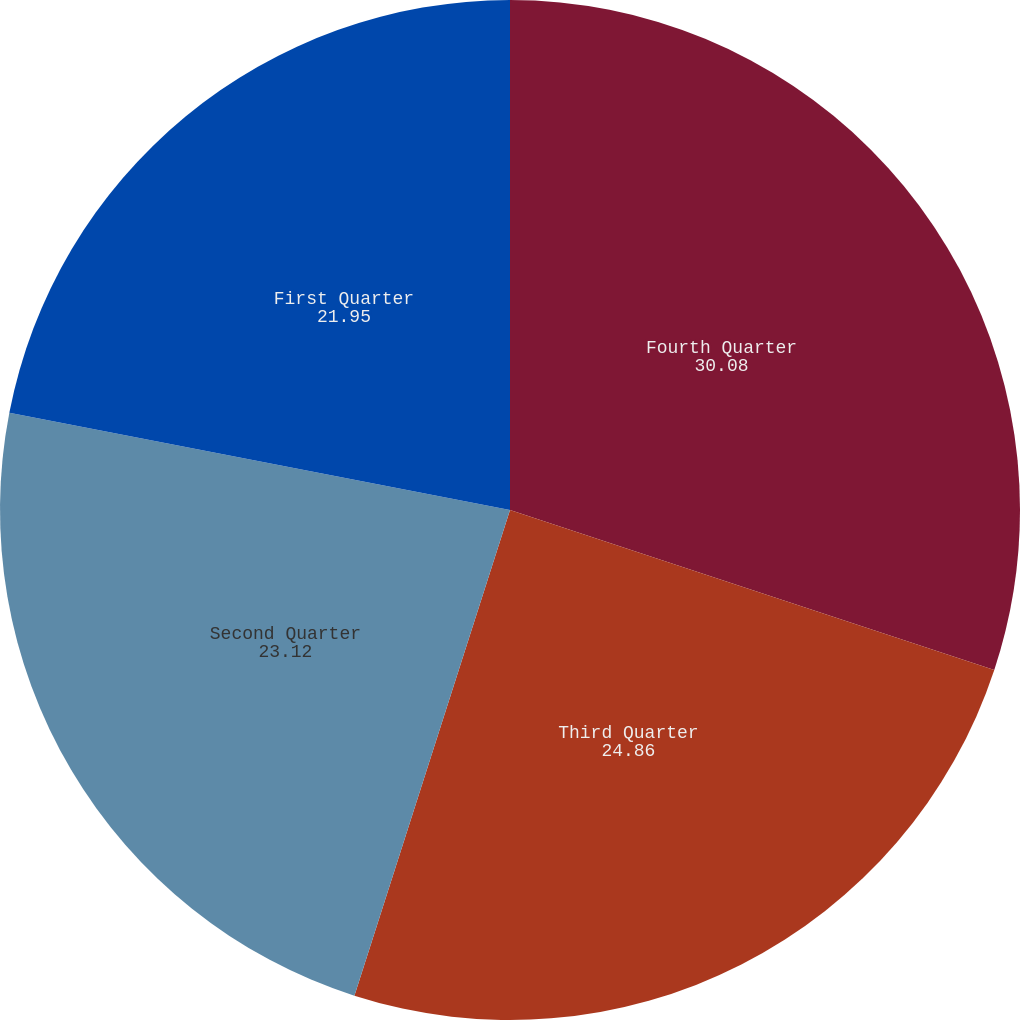Convert chart. <chart><loc_0><loc_0><loc_500><loc_500><pie_chart><fcel>Fourth Quarter<fcel>Third Quarter<fcel>Second Quarter<fcel>First Quarter<nl><fcel>30.08%<fcel>24.86%<fcel>23.12%<fcel>21.95%<nl></chart> 